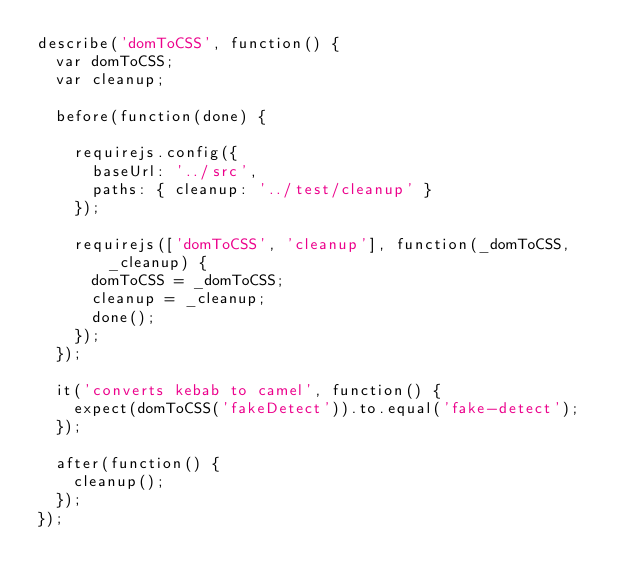<code> <loc_0><loc_0><loc_500><loc_500><_JavaScript_>describe('domToCSS', function() {
  var domToCSS;
  var cleanup;

  before(function(done) {

    requirejs.config({
      baseUrl: '../src',
      paths: { cleanup: '../test/cleanup' }
    });

    requirejs(['domToCSS', 'cleanup'], function(_domToCSS, _cleanup) {
      domToCSS = _domToCSS;
      cleanup = _cleanup;
      done();
    });
  });

  it('converts kebab to camel', function() {
    expect(domToCSS('fakeDetect')).to.equal('fake-detect');
  });

  after(function() {
    cleanup();
  });
});
</code> 